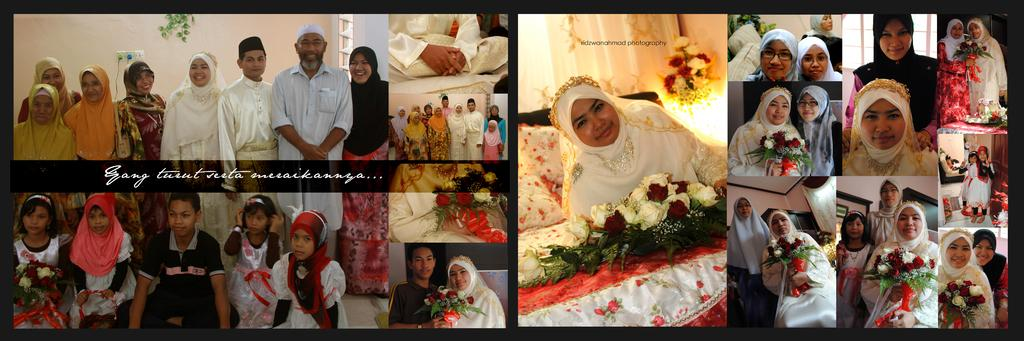What type of clothing can be seen on some of the people in the image? There are people wearing kurtas, burkas, and caps in the image. What items are present in the image that might be used for decoration or celebration? There are flower bouquets in the image. What type of material is visible in the image? There are cloths in the image. What type of vegetation can be seen in the image? There are plants in the image. What structures are present in the image? There is a wall and a bed in the image. What type of drum can be heard playing in the background of the image? There is no drum or sound present in the image; it is a still photograph. Can you describe the cave that is visible in the image? There is no cave present in the image. 